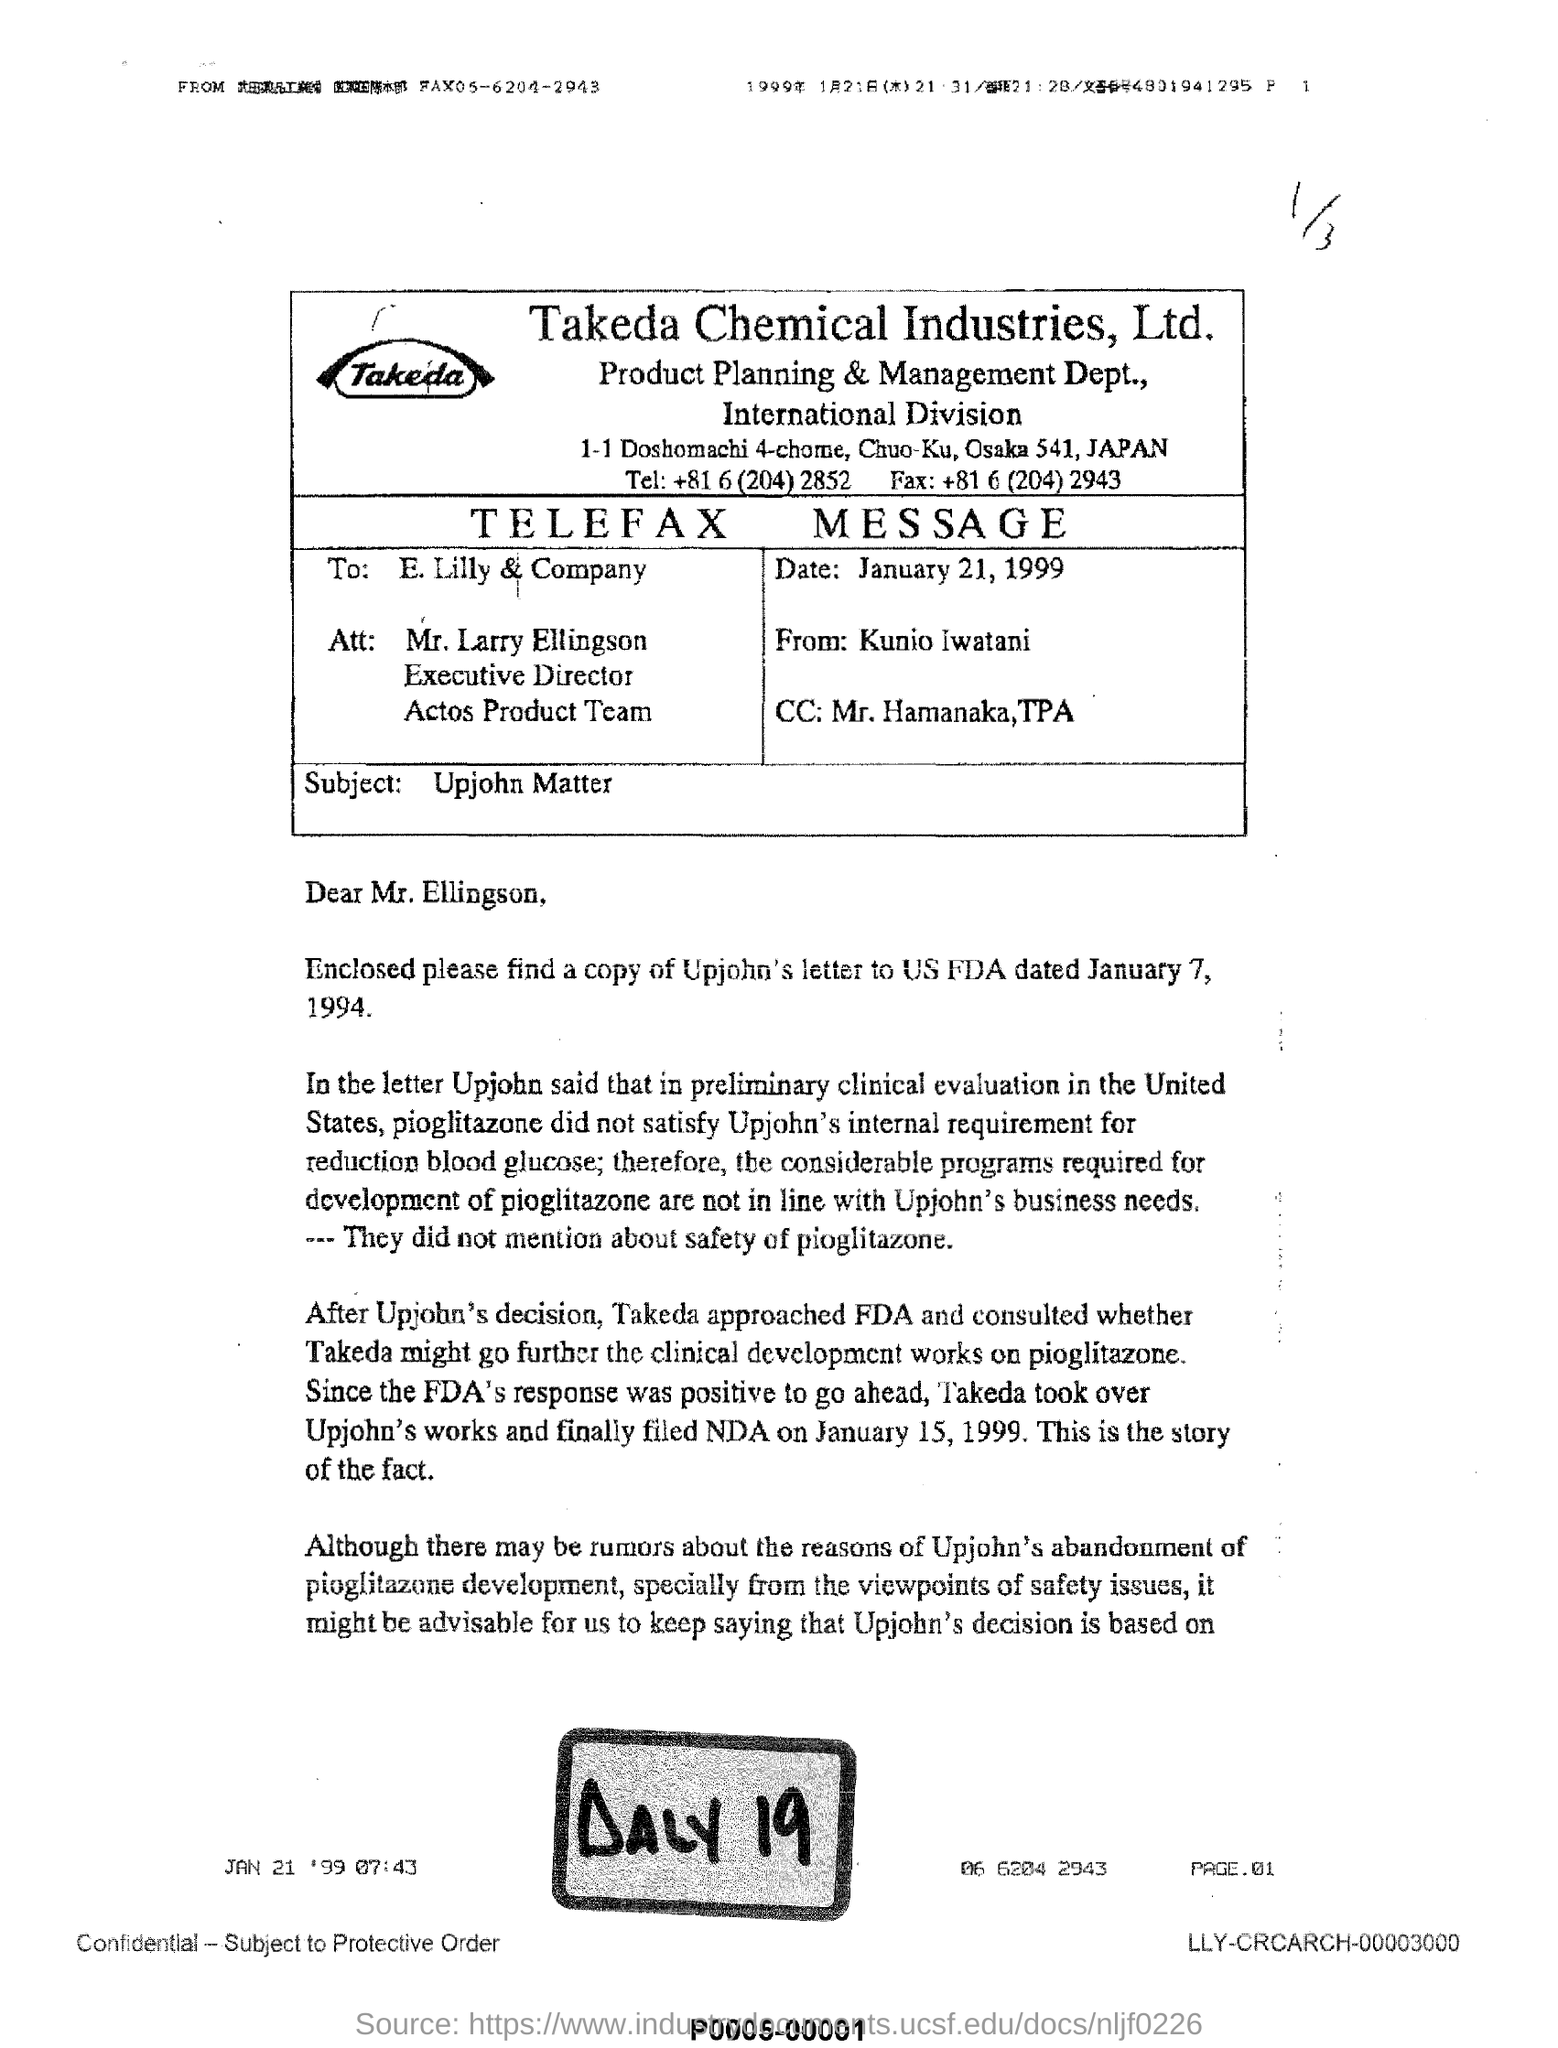What is the date mentioned?
Your answer should be compact. January 21, 1999. To whom is this document addressed?
Your answer should be very brief. Mr. Larry Ellingson. By whom is this document written?
Your answer should be compact. Kunio Iwatani. What is written in big bold letters at the bottom?
Ensure brevity in your answer.  DALY 19. 